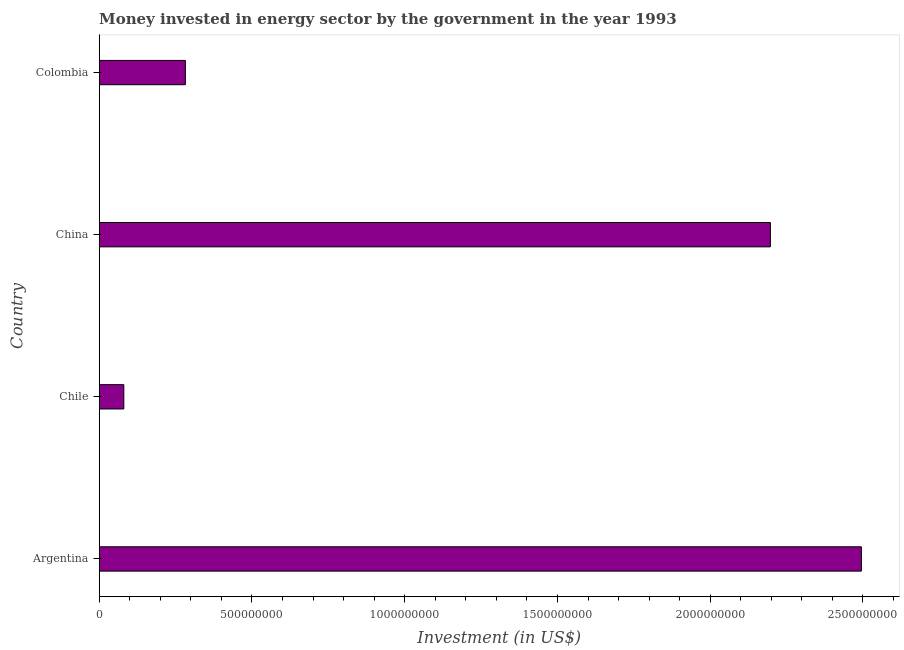Does the graph contain any zero values?
Provide a succinct answer. No. What is the title of the graph?
Provide a short and direct response. Money invested in energy sector by the government in the year 1993. What is the label or title of the X-axis?
Offer a terse response. Investment (in US$). What is the investment in energy in Argentina?
Your answer should be compact. 2.49e+09. Across all countries, what is the maximum investment in energy?
Make the answer very short. 2.49e+09. Across all countries, what is the minimum investment in energy?
Your answer should be very brief. 8.05e+07. In which country was the investment in energy maximum?
Keep it short and to the point. Argentina. In which country was the investment in energy minimum?
Give a very brief answer. Chile. What is the sum of the investment in energy?
Provide a succinct answer. 5.05e+09. What is the difference between the investment in energy in Argentina and Chile?
Give a very brief answer. 2.41e+09. What is the average investment in energy per country?
Provide a succinct answer. 1.26e+09. What is the median investment in energy?
Keep it short and to the point. 1.24e+09. What is the ratio of the investment in energy in China to that in Colombia?
Your response must be concise. 7.79. Is the investment in energy in Chile less than that in China?
Keep it short and to the point. Yes. What is the difference between the highest and the second highest investment in energy?
Provide a short and direct response. 2.98e+08. What is the difference between the highest and the lowest investment in energy?
Provide a succinct answer. 2.41e+09. In how many countries, is the investment in energy greater than the average investment in energy taken over all countries?
Ensure brevity in your answer.  2. How many bars are there?
Give a very brief answer. 4. Are all the bars in the graph horizontal?
Your answer should be very brief. Yes. What is the Investment (in US$) of Argentina?
Ensure brevity in your answer.  2.49e+09. What is the Investment (in US$) of Chile?
Offer a terse response. 8.05e+07. What is the Investment (in US$) of China?
Ensure brevity in your answer.  2.20e+09. What is the Investment (in US$) in Colombia?
Ensure brevity in your answer.  2.82e+08. What is the difference between the Investment (in US$) in Argentina and Chile?
Your answer should be compact. 2.41e+09. What is the difference between the Investment (in US$) in Argentina and China?
Your response must be concise. 2.98e+08. What is the difference between the Investment (in US$) in Argentina and Colombia?
Make the answer very short. 2.21e+09. What is the difference between the Investment (in US$) in Chile and China?
Provide a short and direct response. -2.12e+09. What is the difference between the Investment (in US$) in Chile and Colombia?
Keep it short and to the point. -2.02e+08. What is the difference between the Investment (in US$) in China and Colombia?
Provide a succinct answer. 1.92e+09. What is the ratio of the Investment (in US$) in Argentina to that in Chile?
Offer a terse response. 30.99. What is the ratio of the Investment (in US$) in Argentina to that in China?
Your response must be concise. 1.14. What is the ratio of the Investment (in US$) in Argentina to that in Colombia?
Make the answer very short. 8.85. What is the ratio of the Investment (in US$) in Chile to that in China?
Ensure brevity in your answer.  0.04. What is the ratio of the Investment (in US$) in Chile to that in Colombia?
Keep it short and to the point. 0.28. What is the ratio of the Investment (in US$) in China to that in Colombia?
Your answer should be very brief. 7.79. 